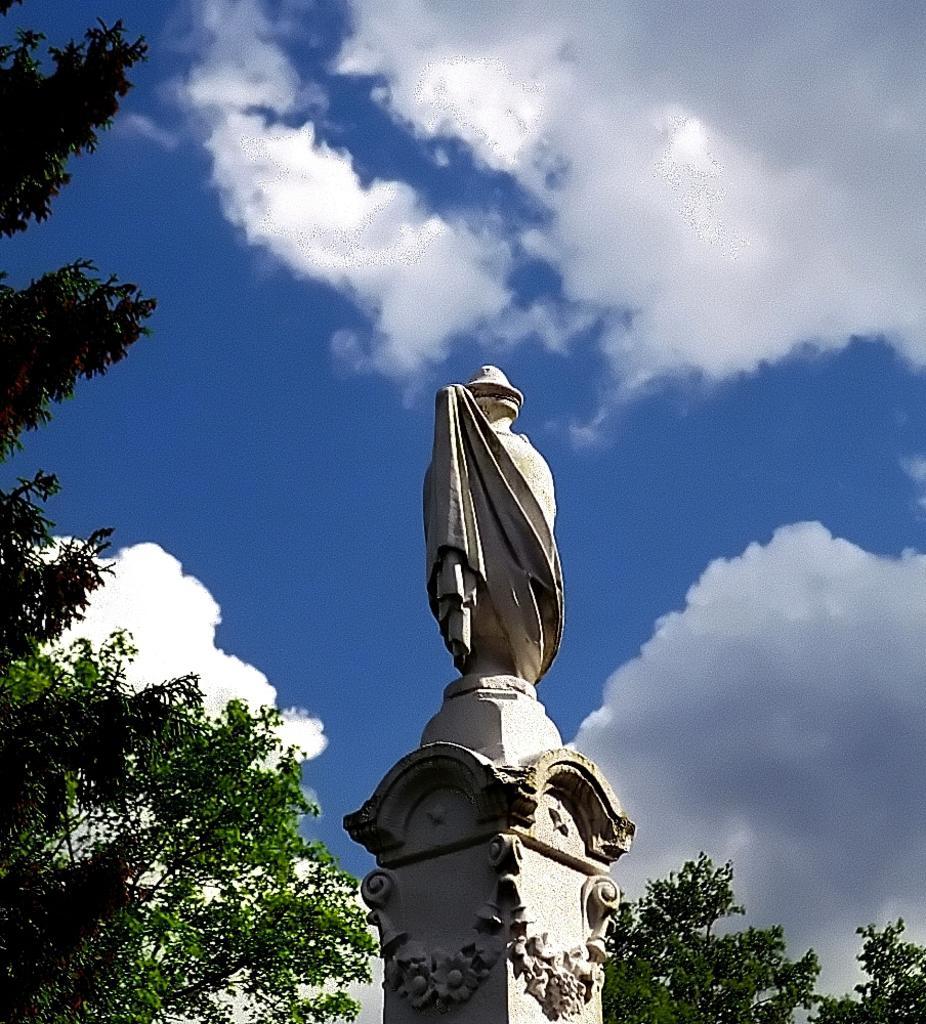Please provide a concise description of this image. Here I can see a statue on a pillar. At the back of it there are some trees. On the top of the image I can see the sky and clouds. 